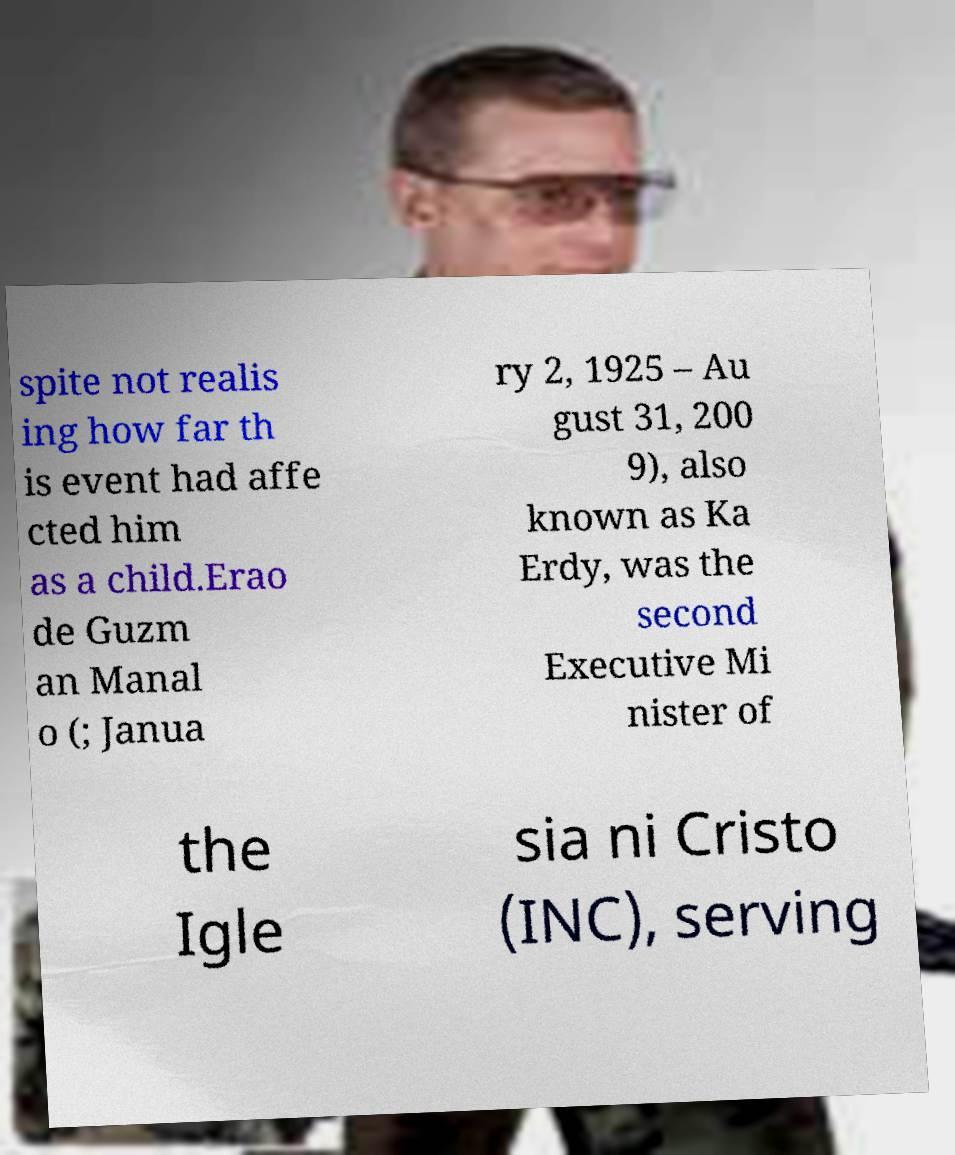For documentation purposes, I need the text within this image transcribed. Could you provide that? spite not realis ing how far th is event had affe cted him as a child.Erao de Guzm an Manal o (; Janua ry 2, 1925 – Au gust 31, 200 9), also known as Ka Erdy, was the second Executive Mi nister of the Igle sia ni Cristo (INC), serving 